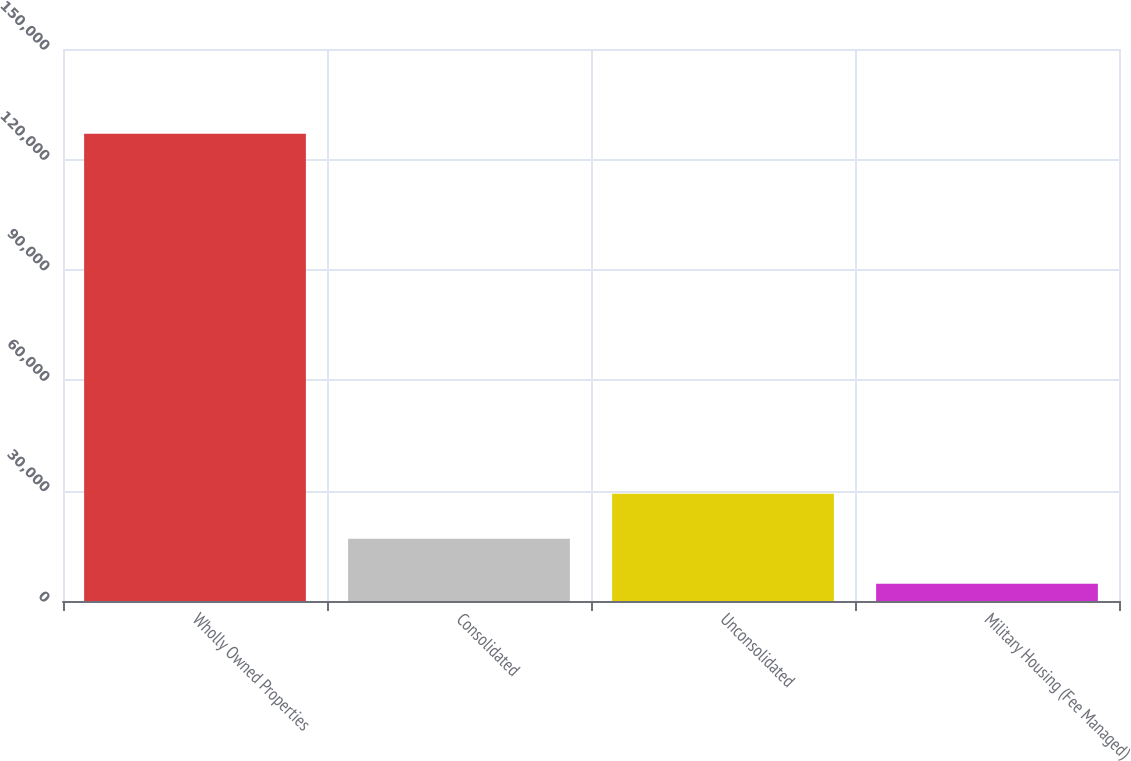<chart> <loc_0><loc_0><loc_500><loc_500><bar_chart><fcel>Wholly Owned Properties<fcel>Consolidated<fcel>Unconsolidated<fcel>Military Housing (Fee Managed)<nl><fcel>127002<fcel>16938.3<fcel>29167.6<fcel>4709<nl></chart> 